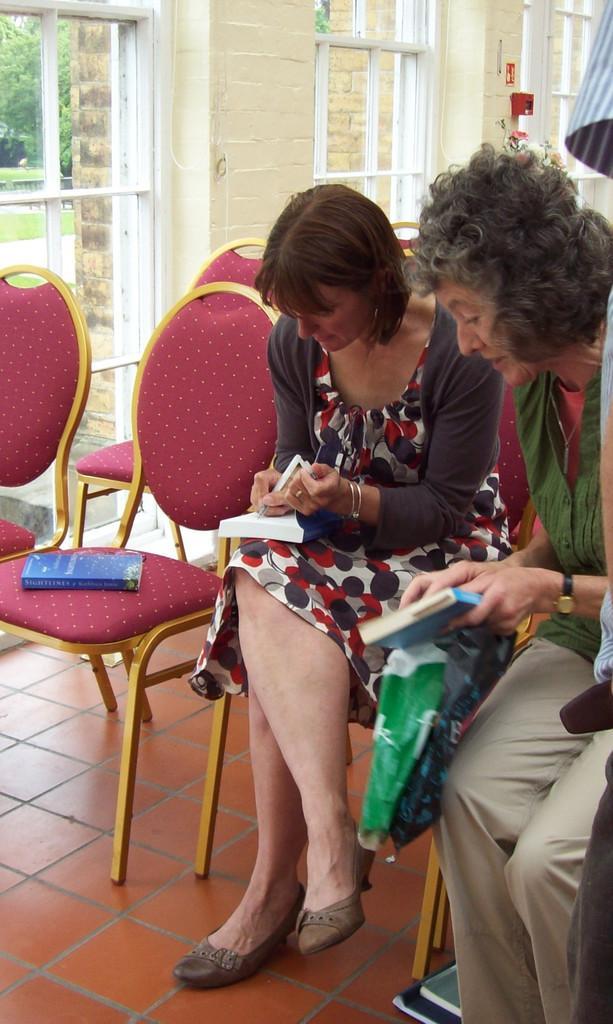Describe this image in one or two sentences. In this image there are two persons sitting on the chairs as we can see in the middle, and there is a wall in the background. There are window glass at the top of this image. 